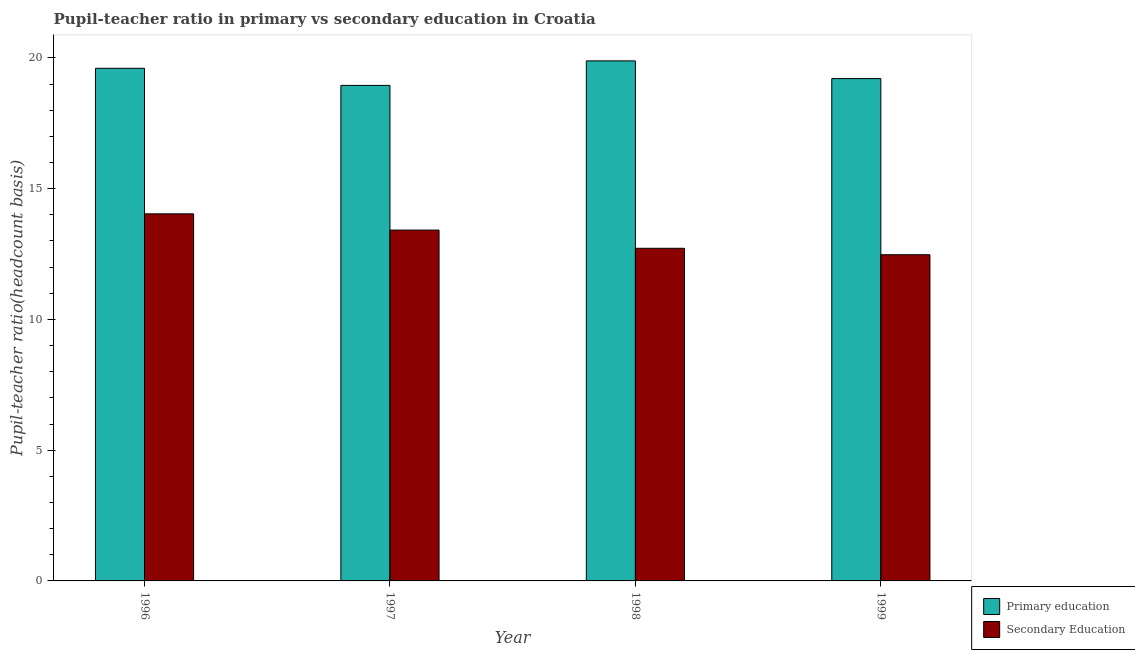How many groups of bars are there?
Your answer should be compact. 4. Are the number of bars per tick equal to the number of legend labels?
Your answer should be very brief. Yes. Are the number of bars on each tick of the X-axis equal?
Your answer should be compact. Yes. How many bars are there on the 4th tick from the left?
Offer a terse response. 2. What is the pupil-teacher ratio in primary education in 1999?
Provide a succinct answer. 19.21. Across all years, what is the maximum pupil-teacher ratio in primary education?
Your answer should be compact. 19.89. Across all years, what is the minimum pupil-teacher ratio in primary education?
Your answer should be very brief. 18.95. What is the total pupil-teacher ratio in primary education in the graph?
Offer a terse response. 77.65. What is the difference between the pupil teacher ratio on secondary education in 1997 and that in 1998?
Provide a succinct answer. 0.7. What is the difference between the pupil-teacher ratio in primary education in 1998 and the pupil teacher ratio on secondary education in 1999?
Keep it short and to the point. 0.68. What is the average pupil teacher ratio on secondary education per year?
Provide a succinct answer. 13.16. In the year 1998, what is the difference between the pupil-teacher ratio in primary education and pupil teacher ratio on secondary education?
Offer a terse response. 0. What is the ratio of the pupil-teacher ratio in primary education in 1997 to that in 1998?
Offer a terse response. 0.95. Is the pupil-teacher ratio in primary education in 1996 less than that in 1998?
Give a very brief answer. Yes. Is the difference between the pupil teacher ratio on secondary education in 1996 and 1997 greater than the difference between the pupil-teacher ratio in primary education in 1996 and 1997?
Provide a succinct answer. No. What is the difference between the highest and the second highest pupil teacher ratio on secondary education?
Offer a very short reply. 0.62. What is the difference between the highest and the lowest pupil teacher ratio on secondary education?
Your answer should be compact. 1.56. In how many years, is the pupil-teacher ratio in primary education greater than the average pupil-teacher ratio in primary education taken over all years?
Make the answer very short. 2. Is the sum of the pupil teacher ratio on secondary education in 1996 and 1998 greater than the maximum pupil-teacher ratio in primary education across all years?
Provide a short and direct response. Yes. What does the 1st bar from the right in 1997 represents?
Keep it short and to the point. Secondary Education. How many bars are there?
Your answer should be very brief. 8. Are all the bars in the graph horizontal?
Keep it short and to the point. No. How many years are there in the graph?
Provide a short and direct response. 4. What is the difference between two consecutive major ticks on the Y-axis?
Offer a very short reply. 5. Does the graph contain grids?
Your answer should be very brief. No. Where does the legend appear in the graph?
Provide a succinct answer. Bottom right. How many legend labels are there?
Your answer should be compact. 2. How are the legend labels stacked?
Provide a short and direct response. Vertical. What is the title of the graph?
Provide a short and direct response. Pupil-teacher ratio in primary vs secondary education in Croatia. What is the label or title of the X-axis?
Give a very brief answer. Year. What is the label or title of the Y-axis?
Provide a short and direct response. Pupil-teacher ratio(headcount basis). What is the Pupil-teacher ratio(headcount basis) in Primary education in 1996?
Provide a short and direct response. 19.6. What is the Pupil-teacher ratio(headcount basis) of Secondary Education in 1996?
Your answer should be compact. 14.04. What is the Pupil-teacher ratio(headcount basis) of Primary education in 1997?
Provide a short and direct response. 18.95. What is the Pupil-teacher ratio(headcount basis) of Secondary Education in 1997?
Offer a terse response. 13.42. What is the Pupil-teacher ratio(headcount basis) of Primary education in 1998?
Offer a terse response. 19.89. What is the Pupil-teacher ratio(headcount basis) of Secondary Education in 1998?
Offer a very short reply. 12.72. What is the Pupil-teacher ratio(headcount basis) in Primary education in 1999?
Your answer should be very brief. 19.21. What is the Pupil-teacher ratio(headcount basis) in Secondary Education in 1999?
Your response must be concise. 12.47. Across all years, what is the maximum Pupil-teacher ratio(headcount basis) of Primary education?
Offer a very short reply. 19.89. Across all years, what is the maximum Pupil-teacher ratio(headcount basis) in Secondary Education?
Your response must be concise. 14.04. Across all years, what is the minimum Pupil-teacher ratio(headcount basis) in Primary education?
Provide a succinct answer. 18.95. Across all years, what is the minimum Pupil-teacher ratio(headcount basis) of Secondary Education?
Keep it short and to the point. 12.47. What is the total Pupil-teacher ratio(headcount basis) of Primary education in the graph?
Provide a short and direct response. 77.65. What is the total Pupil-teacher ratio(headcount basis) in Secondary Education in the graph?
Offer a terse response. 52.65. What is the difference between the Pupil-teacher ratio(headcount basis) in Primary education in 1996 and that in 1997?
Your answer should be compact. 0.65. What is the difference between the Pupil-teacher ratio(headcount basis) of Secondary Education in 1996 and that in 1997?
Your answer should be very brief. 0.62. What is the difference between the Pupil-teacher ratio(headcount basis) of Primary education in 1996 and that in 1998?
Provide a succinct answer. -0.28. What is the difference between the Pupil-teacher ratio(headcount basis) in Secondary Education in 1996 and that in 1998?
Your answer should be compact. 1.32. What is the difference between the Pupil-teacher ratio(headcount basis) in Primary education in 1996 and that in 1999?
Your response must be concise. 0.39. What is the difference between the Pupil-teacher ratio(headcount basis) of Secondary Education in 1996 and that in 1999?
Offer a terse response. 1.56. What is the difference between the Pupil-teacher ratio(headcount basis) in Primary education in 1997 and that in 1998?
Ensure brevity in your answer.  -0.94. What is the difference between the Pupil-teacher ratio(headcount basis) of Secondary Education in 1997 and that in 1998?
Ensure brevity in your answer.  0.7. What is the difference between the Pupil-teacher ratio(headcount basis) in Primary education in 1997 and that in 1999?
Offer a terse response. -0.26. What is the difference between the Pupil-teacher ratio(headcount basis) of Secondary Education in 1997 and that in 1999?
Ensure brevity in your answer.  0.94. What is the difference between the Pupil-teacher ratio(headcount basis) in Primary education in 1998 and that in 1999?
Offer a very short reply. 0.68. What is the difference between the Pupil-teacher ratio(headcount basis) in Secondary Education in 1998 and that in 1999?
Your response must be concise. 0.25. What is the difference between the Pupil-teacher ratio(headcount basis) in Primary education in 1996 and the Pupil-teacher ratio(headcount basis) in Secondary Education in 1997?
Keep it short and to the point. 6.19. What is the difference between the Pupil-teacher ratio(headcount basis) in Primary education in 1996 and the Pupil-teacher ratio(headcount basis) in Secondary Education in 1998?
Your answer should be very brief. 6.88. What is the difference between the Pupil-teacher ratio(headcount basis) of Primary education in 1996 and the Pupil-teacher ratio(headcount basis) of Secondary Education in 1999?
Your answer should be very brief. 7.13. What is the difference between the Pupil-teacher ratio(headcount basis) in Primary education in 1997 and the Pupil-teacher ratio(headcount basis) in Secondary Education in 1998?
Provide a short and direct response. 6.23. What is the difference between the Pupil-teacher ratio(headcount basis) in Primary education in 1997 and the Pupil-teacher ratio(headcount basis) in Secondary Education in 1999?
Offer a terse response. 6.48. What is the difference between the Pupil-teacher ratio(headcount basis) of Primary education in 1998 and the Pupil-teacher ratio(headcount basis) of Secondary Education in 1999?
Provide a short and direct response. 7.41. What is the average Pupil-teacher ratio(headcount basis) in Primary education per year?
Give a very brief answer. 19.41. What is the average Pupil-teacher ratio(headcount basis) of Secondary Education per year?
Provide a short and direct response. 13.16. In the year 1996, what is the difference between the Pupil-teacher ratio(headcount basis) of Primary education and Pupil-teacher ratio(headcount basis) of Secondary Education?
Offer a very short reply. 5.57. In the year 1997, what is the difference between the Pupil-teacher ratio(headcount basis) in Primary education and Pupil-teacher ratio(headcount basis) in Secondary Education?
Offer a terse response. 5.53. In the year 1998, what is the difference between the Pupil-teacher ratio(headcount basis) in Primary education and Pupil-teacher ratio(headcount basis) in Secondary Education?
Ensure brevity in your answer.  7.17. In the year 1999, what is the difference between the Pupil-teacher ratio(headcount basis) of Primary education and Pupil-teacher ratio(headcount basis) of Secondary Education?
Provide a succinct answer. 6.74. What is the ratio of the Pupil-teacher ratio(headcount basis) in Primary education in 1996 to that in 1997?
Provide a short and direct response. 1.03. What is the ratio of the Pupil-teacher ratio(headcount basis) of Secondary Education in 1996 to that in 1997?
Offer a very short reply. 1.05. What is the ratio of the Pupil-teacher ratio(headcount basis) in Primary education in 1996 to that in 1998?
Keep it short and to the point. 0.99. What is the ratio of the Pupil-teacher ratio(headcount basis) in Secondary Education in 1996 to that in 1998?
Provide a succinct answer. 1.1. What is the ratio of the Pupil-teacher ratio(headcount basis) in Primary education in 1996 to that in 1999?
Ensure brevity in your answer.  1.02. What is the ratio of the Pupil-teacher ratio(headcount basis) of Secondary Education in 1996 to that in 1999?
Provide a succinct answer. 1.13. What is the ratio of the Pupil-teacher ratio(headcount basis) of Primary education in 1997 to that in 1998?
Provide a succinct answer. 0.95. What is the ratio of the Pupil-teacher ratio(headcount basis) in Secondary Education in 1997 to that in 1998?
Offer a terse response. 1.05. What is the ratio of the Pupil-teacher ratio(headcount basis) of Primary education in 1997 to that in 1999?
Ensure brevity in your answer.  0.99. What is the ratio of the Pupil-teacher ratio(headcount basis) in Secondary Education in 1997 to that in 1999?
Keep it short and to the point. 1.08. What is the ratio of the Pupil-teacher ratio(headcount basis) of Primary education in 1998 to that in 1999?
Offer a very short reply. 1.04. What is the ratio of the Pupil-teacher ratio(headcount basis) in Secondary Education in 1998 to that in 1999?
Your answer should be compact. 1.02. What is the difference between the highest and the second highest Pupil-teacher ratio(headcount basis) in Primary education?
Give a very brief answer. 0.28. What is the difference between the highest and the second highest Pupil-teacher ratio(headcount basis) in Secondary Education?
Offer a terse response. 0.62. What is the difference between the highest and the lowest Pupil-teacher ratio(headcount basis) in Primary education?
Keep it short and to the point. 0.94. What is the difference between the highest and the lowest Pupil-teacher ratio(headcount basis) of Secondary Education?
Provide a short and direct response. 1.56. 